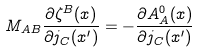Convert formula to latex. <formula><loc_0><loc_0><loc_500><loc_500>M _ { A B } \frac { \partial \zeta ^ { B } ( x ) } { \partial j _ { C } ( x ^ { \prime } ) } = - \frac { \partial A _ { A } ^ { 0 } ( x ) } { \partial j _ { C } ( x ^ { \prime } ) }</formula> 